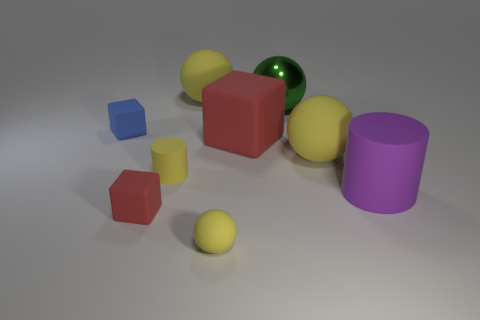Subtract all yellow blocks. How many yellow balls are left? 3 Subtract all red spheres. Subtract all cyan cylinders. How many spheres are left? 4 Add 1 small yellow things. How many objects exist? 10 Subtract all cubes. How many objects are left? 6 Subtract 0 gray cylinders. How many objects are left? 9 Subtract all matte objects. Subtract all large metal spheres. How many objects are left? 0 Add 3 small rubber objects. How many small rubber objects are left? 7 Add 2 big green spheres. How many big green spheres exist? 3 